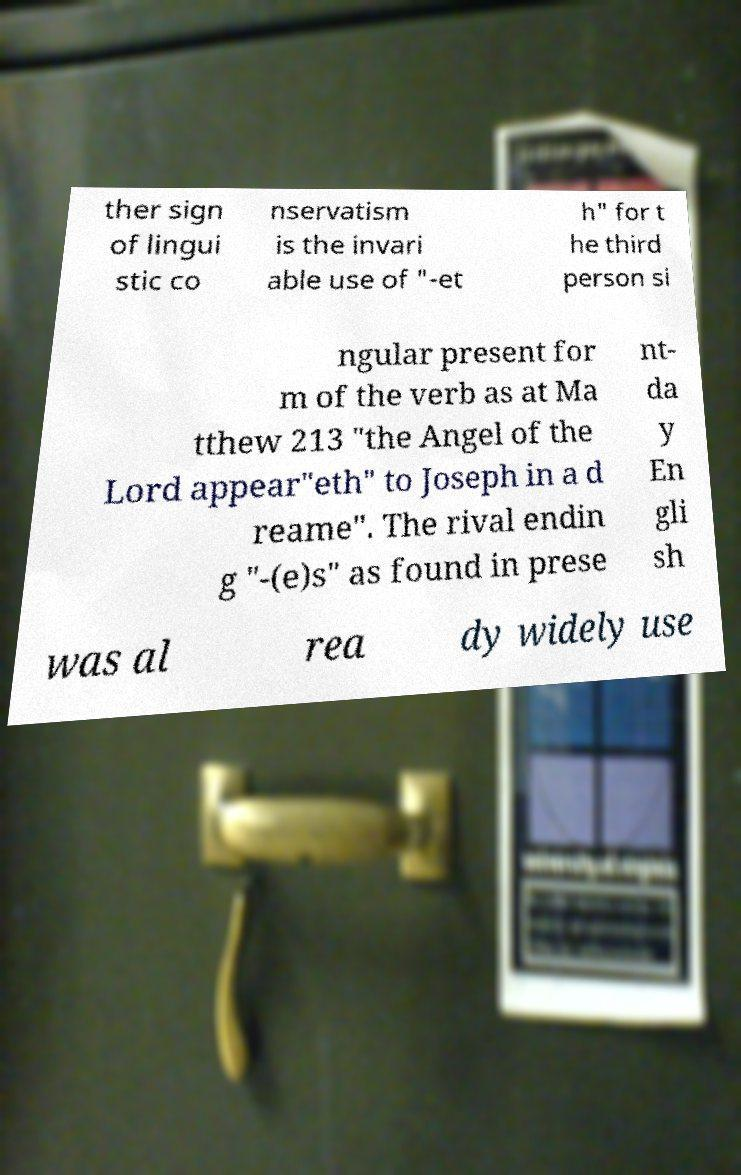Could you extract and type out the text from this image? ther sign of lingui stic co nservatism is the invari able use of "-et h" for t he third person si ngular present for m of the verb as at Ma tthew 213 "the Angel of the Lord appear"eth" to Joseph in a d reame". The rival endin g "-(e)s" as found in prese nt- da y En gli sh was al rea dy widely use 